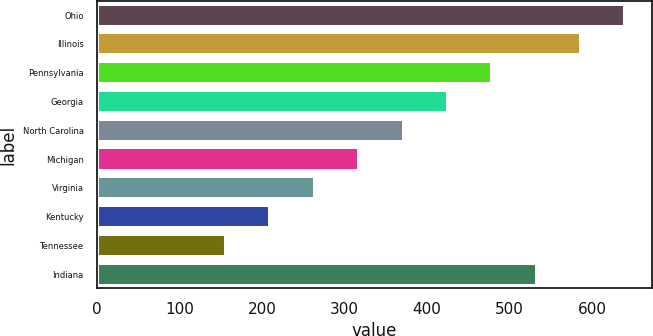Convert chart. <chart><loc_0><loc_0><loc_500><loc_500><bar_chart><fcel>Ohio<fcel>Illinois<fcel>Pennsylvania<fcel>Georgia<fcel>North Carolina<fcel>Michigan<fcel>Virginia<fcel>Kentucky<fcel>Tennessee<fcel>Indiana<nl><fcel>640<fcel>586.3<fcel>478.9<fcel>425.2<fcel>371.5<fcel>317.8<fcel>264.1<fcel>210.4<fcel>156.7<fcel>532.6<nl></chart> 